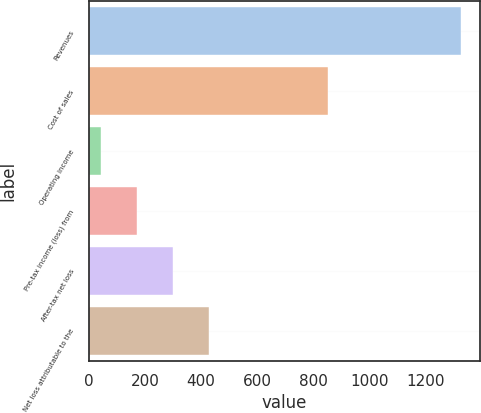Convert chart to OTSL. <chart><loc_0><loc_0><loc_500><loc_500><bar_chart><fcel>Revenues<fcel>Cost of sales<fcel>Operating income<fcel>Pre-tax income (loss) from<fcel>After-tax net loss<fcel>Net loss attributable to the<nl><fcel>1324<fcel>853<fcel>42<fcel>170.2<fcel>298.4<fcel>426.6<nl></chart> 